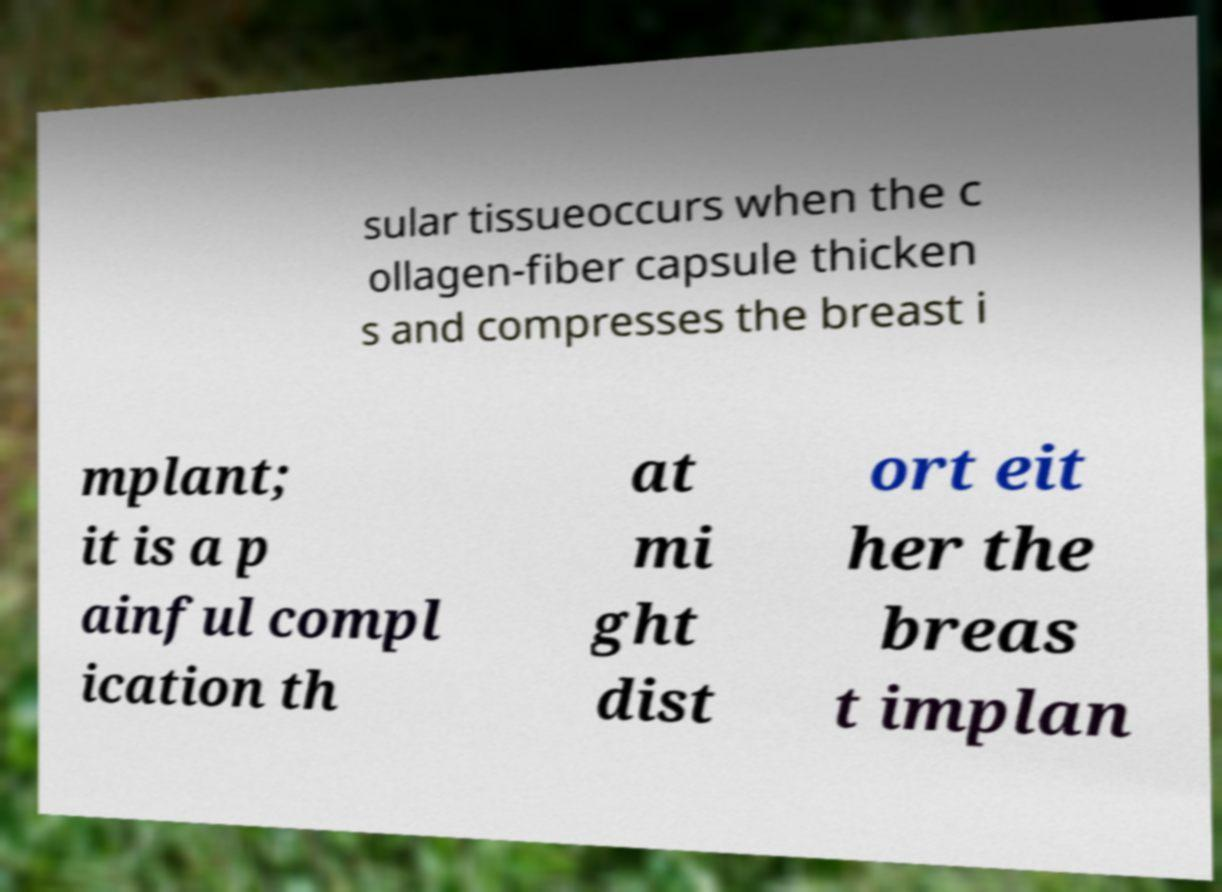What messages or text are displayed in this image? I need them in a readable, typed format. sular tissueoccurs when the c ollagen-fiber capsule thicken s and compresses the breast i mplant; it is a p ainful compl ication th at mi ght dist ort eit her the breas t implan 